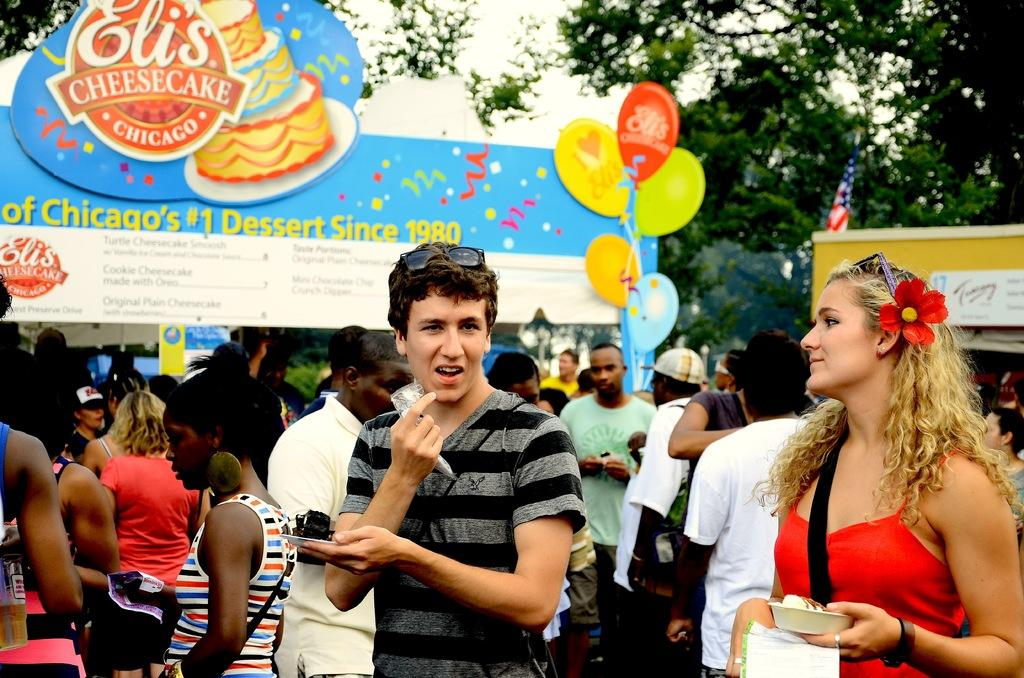What is the main subject of the image? The main subject of the image is a group of people. What can be seen in the background of the image? In the background of the image, there are name boards and trees. What type of soap is being used by the people in the image? There is no soap present in the image; it features a group of people and background elements. 